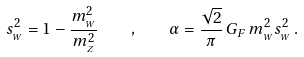<formula> <loc_0><loc_0><loc_500><loc_500>s _ { _ { W } } ^ { 2 } = 1 - \frac { m _ { _ { W } } ^ { 2 } } { m _ { _ { Z } } ^ { 2 } } \quad , \quad \alpha = \frac { \sqrt { 2 } } { \pi } \, G _ { F } \, m _ { _ { W } } ^ { 2 } s _ { _ { W } } ^ { 2 } \, .</formula> 